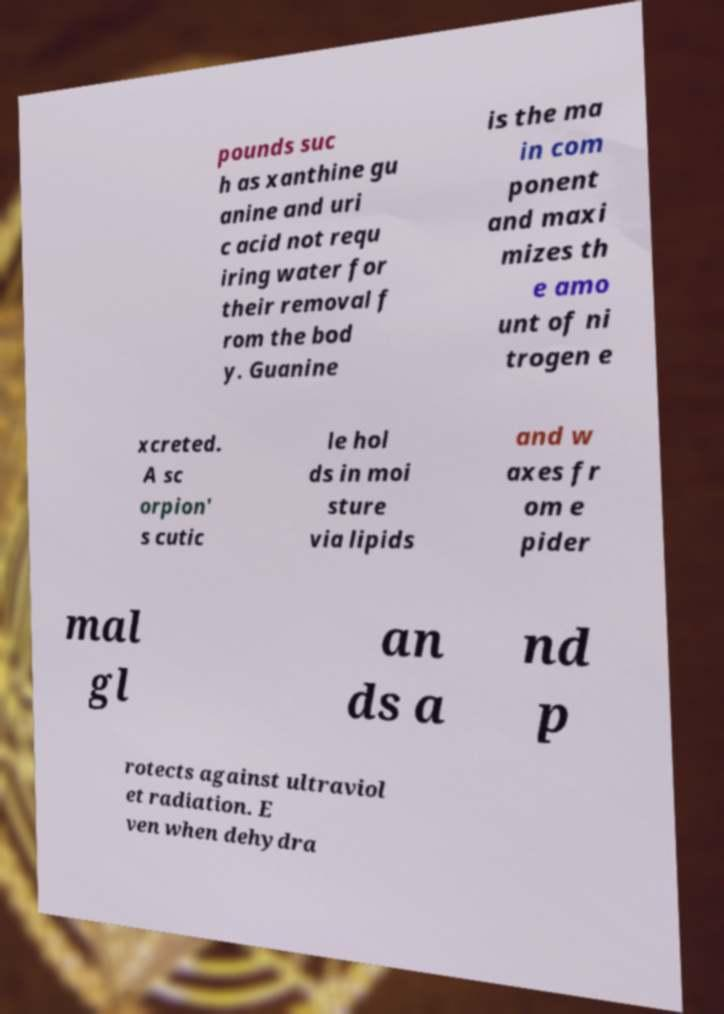Can you read and provide the text displayed in the image?This photo seems to have some interesting text. Can you extract and type it out for me? pounds suc h as xanthine gu anine and uri c acid not requ iring water for their removal f rom the bod y. Guanine is the ma in com ponent and maxi mizes th e amo unt of ni trogen e xcreted. A sc orpion' s cutic le hol ds in moi sture via lipids and w axes fr om e pider mal gl an ds a nd p rotects against ultraviol et radiation. E ven when dehydra 